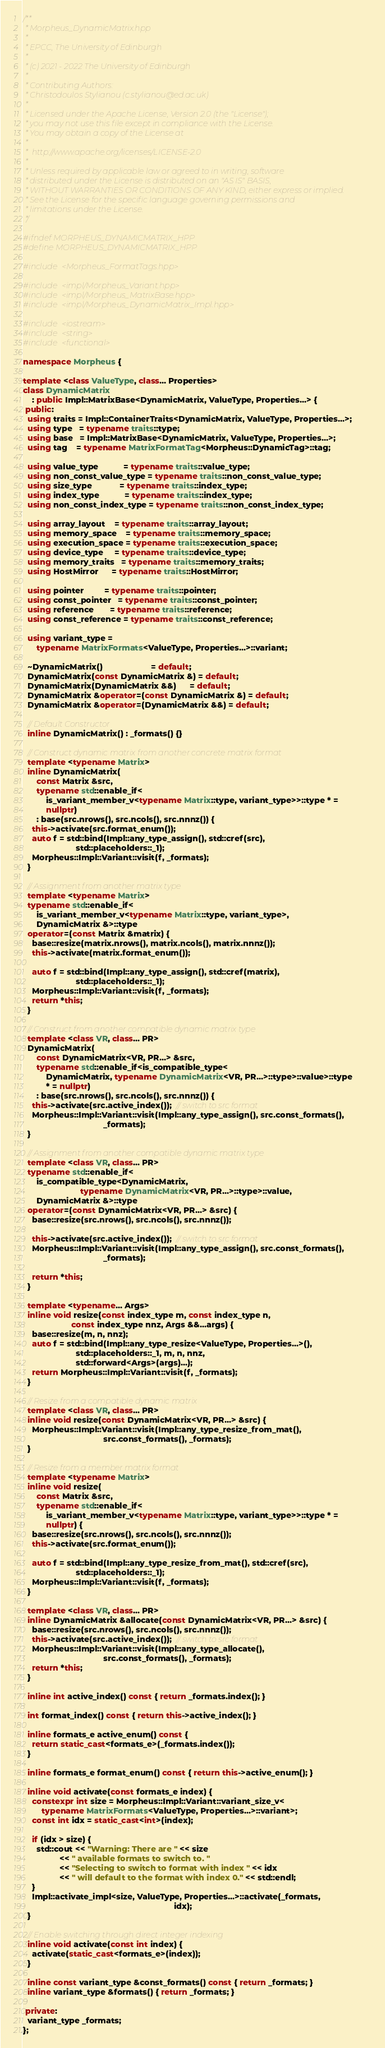Convert code to text. <code><loc_0><loc_0><loc_500><loc_500><_C++_>/**
 * Morpheus_DynamicMatrix.hpp
 *
 * EPCC, The University of Edinburgh
 *
 * (c) 2021 - 2022 The University of Edinburgh
 *
 * Contributing Authors:
 * Christodoulos Stylianou (c.stylianou@ed.ac.uk)
 *
 * Licensed under the Apache License, Version 2.0 (the "License");
 * you may not use this file except in compliance with the License.
 * You may obtain a copy of the License at
 *
 * 	http://www.apache.org/licenses/LICENSE-2.0
 *
 * Unless required by applicable law or agreed to in writing, software
 * distributed under the License is distributed on an "AS IS" BASIS,
 * WITHOUT WARRANTIES OR CONDITIONS OF ANY KIND, either express or implied.
 * See the License for the specific language governing permissions and
 * limitations under the License.
 */

#ifndef MORPHEUS_DYNAMICMATRIX_HPP
#define MORPHEUS_DYNAMICMATRIX_HPP

#include <Morpheus_FormatTags.hpp>

#include <impl/Morpheus_Variant.hpp>
#include <impl/Morpheus_MatrixBase.hpp>
#include <impl/Morpheus_DynamicMatrix_Impl.hpp>

#include <iostream>
#include <string>
#include <functional>

namespace Morpheus {

template <class ValueType, class... Properties>
class DynamicMatrix
    : public Impl::MatrixBase<DynamicMatrix, ValueType, Properties...> {
 public:
  using traits = Impl::ContainerTraits<DynamicMatrix, ValueType, Properties...>;
  using type   = typename traits::type;
  using base   = Impl::MatrixBase<DynamicMatrix, ValueType, Properties...>;
  using tag    = typename MatrixFormatTag<Morpheus::DynamicTag>::tag;

  using value_type           = typename traits::value_type;
  using non_const_value_type = typename traits::non_const_value_type;
  using size_type            = typename traits::index_type;
  using index_type           = typename traits::index_type;
  using non_const_index_type = typename traits::non_const_index_type;

  using array_layout    = typename traits::array_layout;
  using memory_space    = typename traits::memory_space;
  using execution_space = typename traits::execution_space;
  using device_type     = typename traits::device_type;
  using memory_traits   = typename traits::memory_traits;
  using HostMirror      = typename traits::HostMirror;

  using pointer         = typename traits::pointer;
  using const_pointer   = typename traits::const_pointer;
  using reference       = typename traits::reference;
  using const_reference = typename traits::const_reference;

  using variant_type =
      typename MatrixFormats<ValueType, Properties...>::variant;

  ~DynamicMatrix()                     = default;
  DynamicMatrix(const DynamicMatrix &) = default;
  DynamicMatrix(DynamicMatrix &&)      = default;
  DynamicMatrix &operator=(const DynamicMatrix &) = default;
  DynamicMatrix &operator=(DynamicMatrix &&) = default;

  // Default Constructor
  inline DynamicMatrix() : _formats() {}

  // Construct dynamic matrix from another concrete matrix format
  template <typename Matrix>
  inline DynamicMatrix(
      const Matrix &src,
      typename std::enable_if<
          is_variant_member_v<typename Matrix::type, variant_type>>::type * =
          nullptr)
      : base(src.nrows(), src.ncols(), src.nnnz()) {
    this->activate(src.format_enum());
    auto f = std::bind(Impl::any_type_assign(), std::cref(src),
                       std::placeholders::_1);
    Morpheus::Impl::Variant::visit(f, _formats);
  }

  // Assignment from another matrix type
  template <typename Matrix>
  typename std::enable_if<
      is_variant_member_v<typename Matrix::type, variant_type>,
      DynamicMatrix &>::type
  operator=(const Matrix &matrix) {
    base::resize(matrix.nrows(), matrix.ncols(), matrix.nnnz());
    this->activate(matrix.format_enum());

    auto f = std::bind(Impl::any_type_assign(), std::cref(matrix),
                       std::placeholders::_1);
    Morpheus::Impl::Variant::visit(f, _formats);
    return *this;
  }

  // Construct from another compatible dynamic matrix type
  template <class VR, class... PR>
  DynamicMatrix(
      const DynamicMatrix<VR, PR...> &src,
      typename std::enable_if<is_compatible_type<
          DynamicMatrix, typename DynamicMatrix<VR, PR...>::type>::value>::type
          * = nullptr)
      : base(src.nrows(), src.ncols(), src.nnnz()) {
    this->activate(src.active_index());  // switch to src format
    Morpheus::Impl::Variant::visit(Impl::any_type_assign(), src.const_formats(),
                                   _formats);
  }

  // Assignment from another compatible dynamic matrix type
  template <class VR, class... PR>
  typename std::enable_if<
      is_compatible_type<DynamicMatrix,
                         typename DynamicMatrix<VR, PR...>::type>::value,
      DynamicMatrix &>::type
  operator=(const DynamicMatrix<VR, PR...> &src) {
    base::resize(src.nrows(), src.ncols(), src.nnnz());

    this->activate(src.active_index());  // switch to src format
    Morpheus::Impl::Variant::visit(Impl::any_type_assign(), src.const_formats(),
                                   _formats);

    return *this;
  }

  template <typename... Args>
  inline void resize(const index_type m, const index_type n,
                     const index_type nnz, Args &&...args) {
    base::resize(m, n, nnz);
    auto f = std::bind(Impl::any_type_resize<ValueType, Properties...>(),
                       std::placeholders::_1, m, n, nnz,
                       std::forward<Args>(args)...);
    return Morpheus::Impl::Variant::visit(f, _formats);
  }

  // Resize from a compatible dynamic matrix
  template <class VR, class... PR>
  inline void resize(const DynamicMatrix<VR, PR...> &src) {
    Morpheus::Impl::Variant::visit(Impl::any_type_resize_from_mat(),
                                   src.const_formats(), _formats);
  }

  // Resize from a member matrix format
  template <typename Matrix>
  inline void resize(
      const Matrix &src,
      typename std::enable_if<
          is_variant_member_v<typename Matrix::type, variant_type>>::type * =
          nullptr) {
    base::resize(src.nrows(), src.ncols(), src.nnnz());
    this->activate(src.format_enum());

    auto f = std::bind(Impl::any_type_resize_from_mat(), std::cref(src),
                       std::placeholders::_1);
    Morpheus::Impl::Variant::visit(f, _formats);
  }

  template <class VR, class... PR>
  inline DynamicMatrix &allocate(const DynamicMatrix<VR, PR...> &src) {
    base::resize(src.nrows(), src.ncols(), src.nnnz());
    this->activate(src.active_index());  // switch to src format
    Morpheus::Impl::Variant::visit(Impl::any_type_allocate(),
                                   src.const_formats(), _formats);
    return *this;
  }

  inline int active_index() const { return _formats.index(); }

  int format_index() const { return this->active_index(); }

  inline formats_e active_enum() const {
    return static_cast<formats_e>(_formats.index());
  }

  inline formats_e format_enum() const { return this->active_enum(); }

  inline void activate(const formats_e index) {
    constexpr int size = Morpheus::Impl::Variant::variant_size_v<
        typename MatrixFormats<ValueType, Properties...>::variant>;
    const int idx = static_cast<int>(index);

    if (idx > size) {
      std::cout << "Warning: There are " << size
                << " available formats to switch to. "
                << "Selecting to switch to format with index " << idx
                << " will default to the format with index 0." << std::endl;
    }
    Impl::activate_impl<size, ValueType, Properties...>::activate(_formats,
                                                                  idx);
  }

  // Enable switching through direct integer indexing
  inline void activate(const int index) {
    activate(static_cast<formats_e>(index));
  }

  inline const variant_type &const_formats() const { return _formats; }
  inline variant_type &formats() { return _formats; }

 private:
  variant_type _formats;
};</code> 